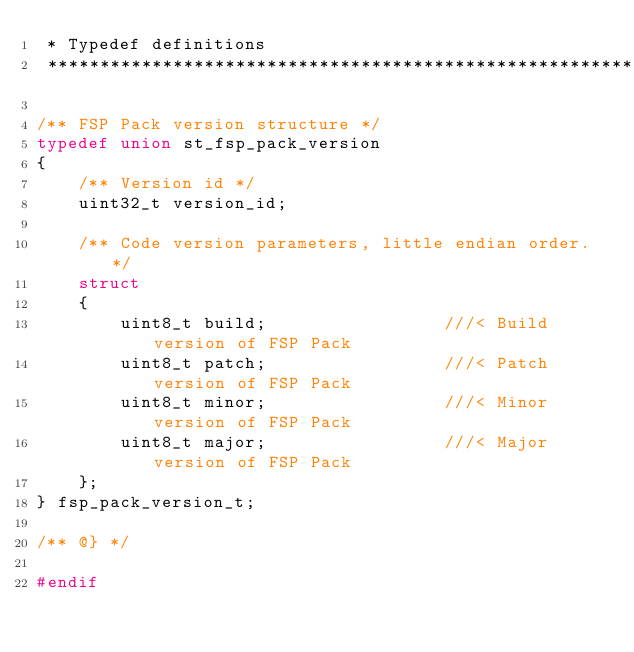Convert code to text. <code><loc_0><loc_0><loc_500><loc_500><_C_> * Typedef definitions
 **********************************************************************************************************************/

/** FSP Pack version structure */
typedef union st_fsp_pack_version
{
    /** Version id */
    uint32_t version_id;

    /** Code version parameters, little endian order. */
    struct
    {
        uint8_t build;                 ///< Build version of FSP Pack
        uint8_t patch;                 ///< Patch version of FSP Pack
        uint8_t minor;                 ///< Minor version of FSP Pack
        uint8_t major;                 ///< Major version of FSP Pack
    };
} fsp_pack_version_t;

/** @} */

#endif
</code> 